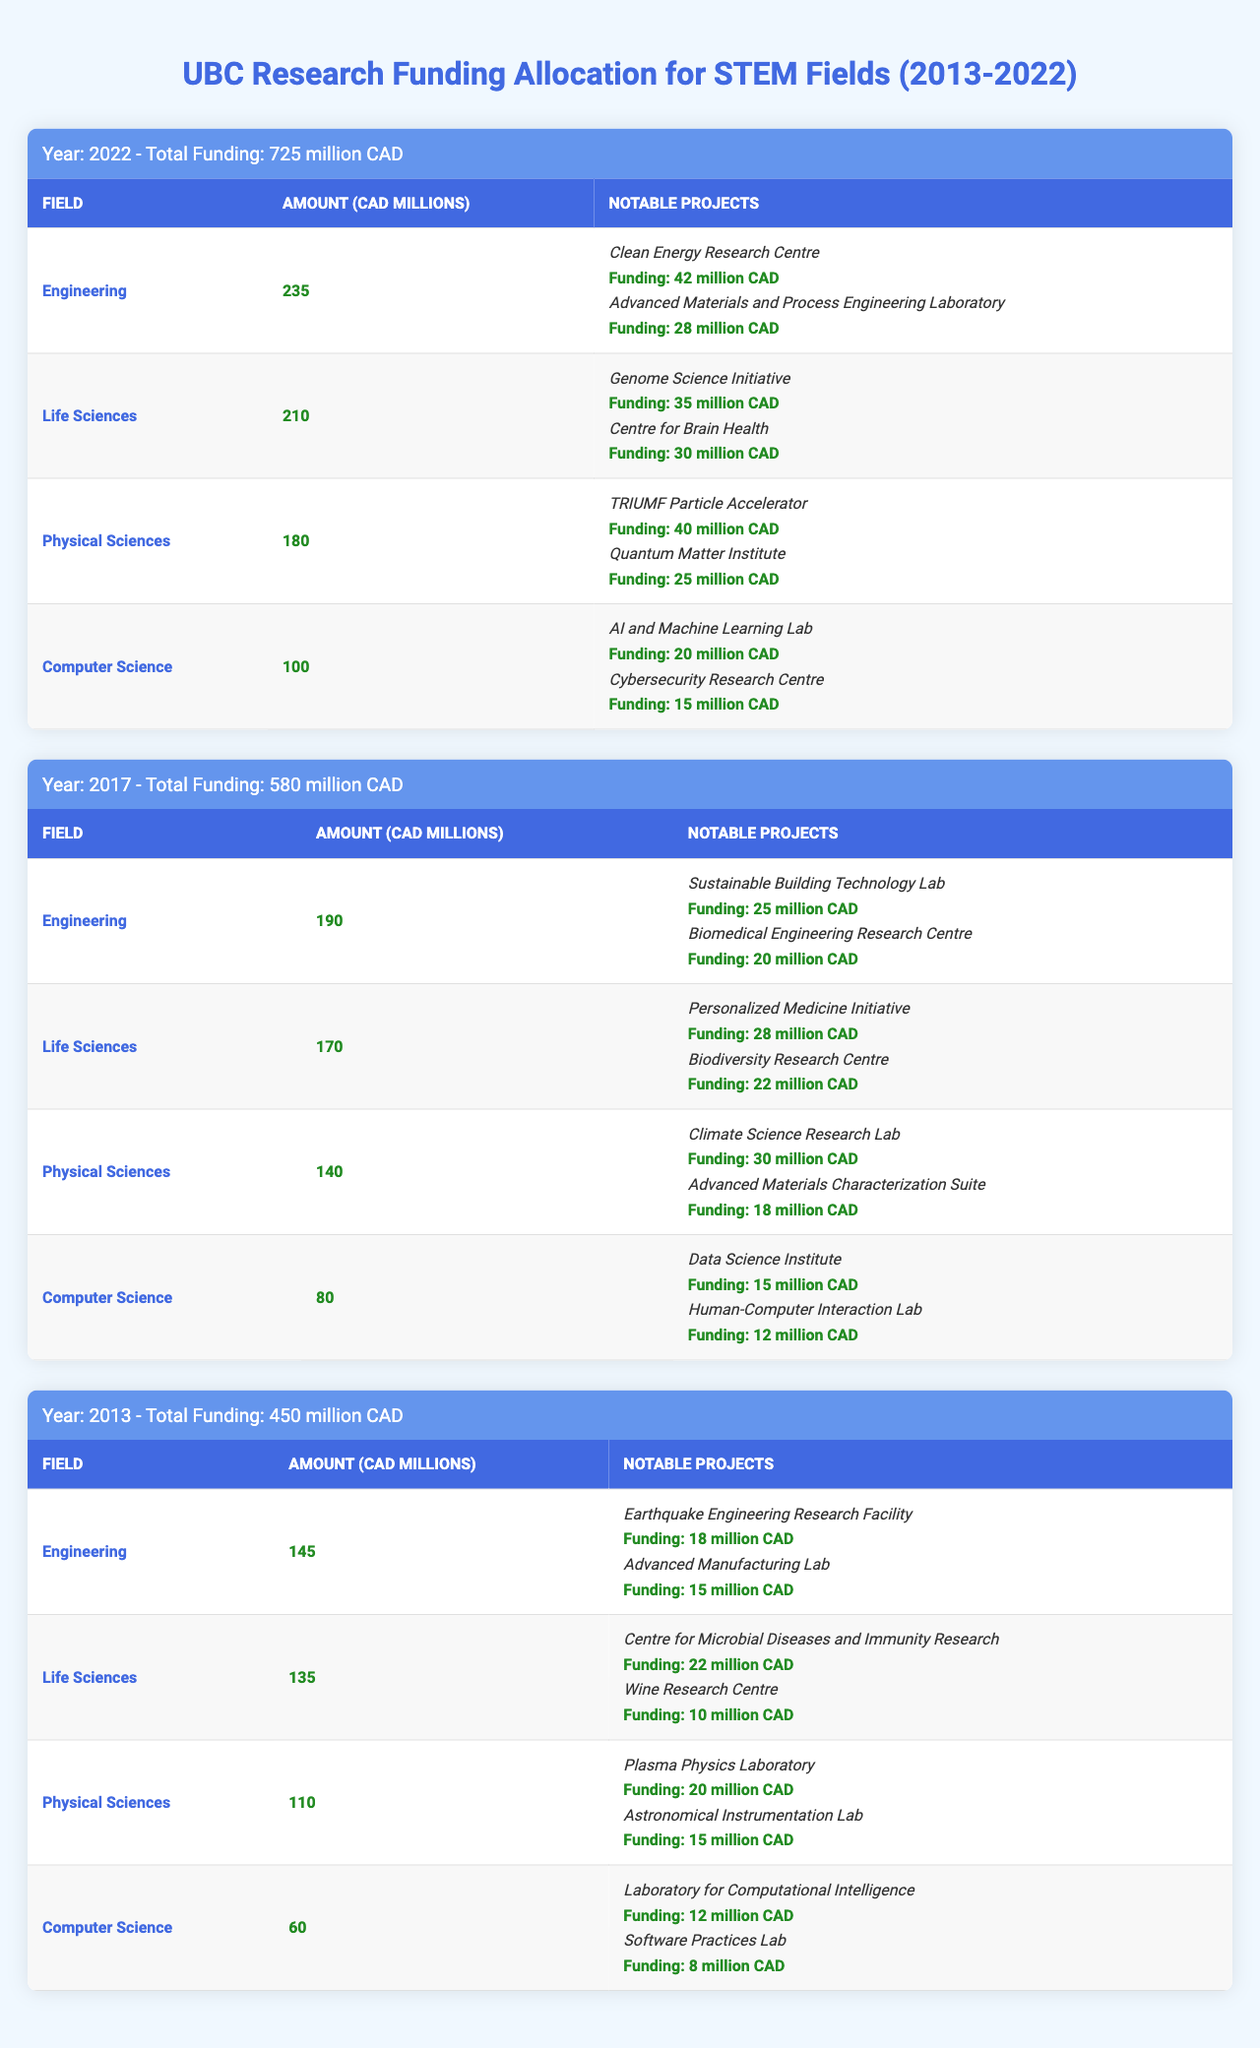What was the total funding allocated for STEM fields at UBC in 2022? The table shows that the total funding for the year 2022 was 725 million CAD.
Answer: 725 million CAD Which field received the highest funding in 2017? In 2017, Engineering received the highest funding of 190 million CAD compared to other fields like Life Sciences, Physical Sciences, and Computer Science.
Answer: Engineering What is the total funding for Physical Sciences across all three years (2022, 2017, and 2013)? From the table, Physical Sciences funding can be summed as follows: 2022: 180 million CAD, 2017: 140 million CAD, 2013: 110 million CAD. Thus, 180 + 140 + 110 = 430 million CAD.
Answer: 430 million CAD Which notable project received the highest funding in the Life Sciences field in 2022? The Life Sciences notable projects listed for 2022 show the Genome Science Initiative received the highest funding of 35 million CAD.
Answer: Genome Science Initiative Was the total funding for Life Sciences in 2013 greater than that of Computer Science in the same year? In 2013, Life Sciences received 135 million CAD while Computer Science received 60 million CAD. Since 135 is greater than 60, the statement is true.
Answer: Yes Calculate the average funding amount for the Engineering field over the years 2022, 2017, and 2013. The funding amounts for Engineering are 235 million CAD (2022), 190 million CAD (2017), and 145 million CAD (2013). The total is 235 + 190 + 145 = 570 million CAD. There are 3 data points, so the average is 570 / 3 = 190 million CAD.
Answer: 190 million CAD In which year did the Computer Science field have the least funding? The table shows Computer Science funding in 2022 was 100 million CAD, 2017 was 80 million CAD, and 2013 was 60 million CAD. Therefore, the least funding was in 2013.
Answer: 2013 Identify the project in Physical Sciences with the lowest funding in 2022. From the notable projects listed under Physical Sciences in 2022, the Quantum Matter Institute received 25 million CAD, which is the lowest funding compared to others.
Answer: Quantum Matter Institute How much more funding did Life Sciences receive than Engineering in 2017? Life Sciences received 170 million CAD and Engineering received 190 million CAD in 2017. Therefore, Engineering received more funding. Calculating the difference: 170 - 190 = -20 million CAD, indicating Engineering had 20 million CAD more.
Answer: Engineering had 20 million CAD more What percentage of the total funding for 2022 was allocated to Computer Science? The total funding for 2022 was 725 million CAD, and Computer Science received 100 million CAD. To find the percentage: (100 / 725) * 100 ≈ 13.79%.
Answer: Approximately 13.79% 